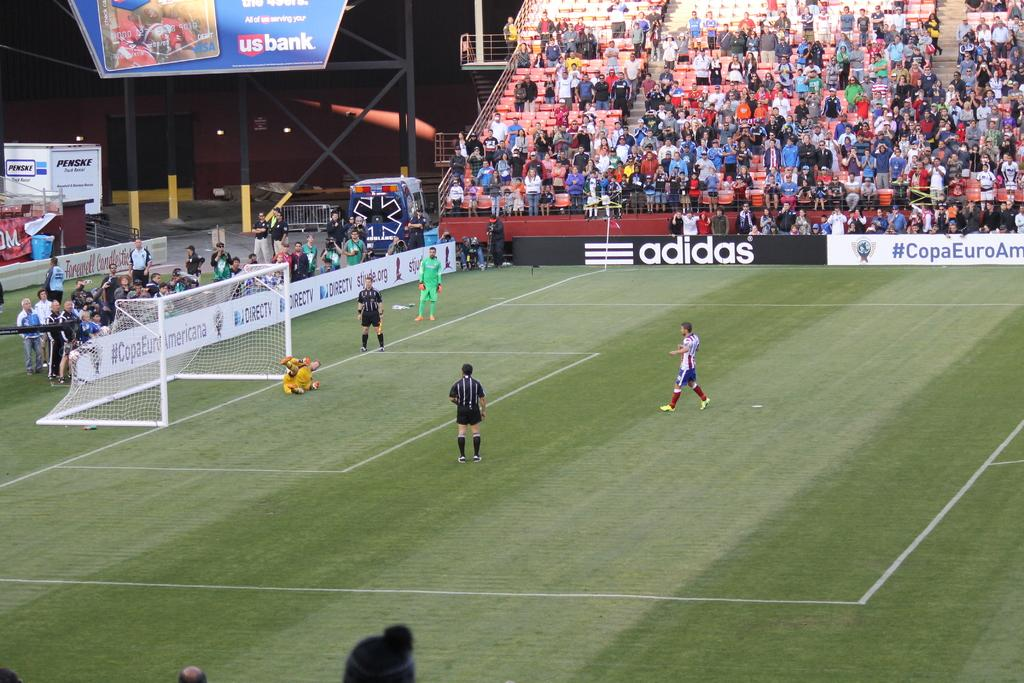<image>
Create a compact narrative representing the image presented. Adidas is a sponsor judging from the banner on the wall. 